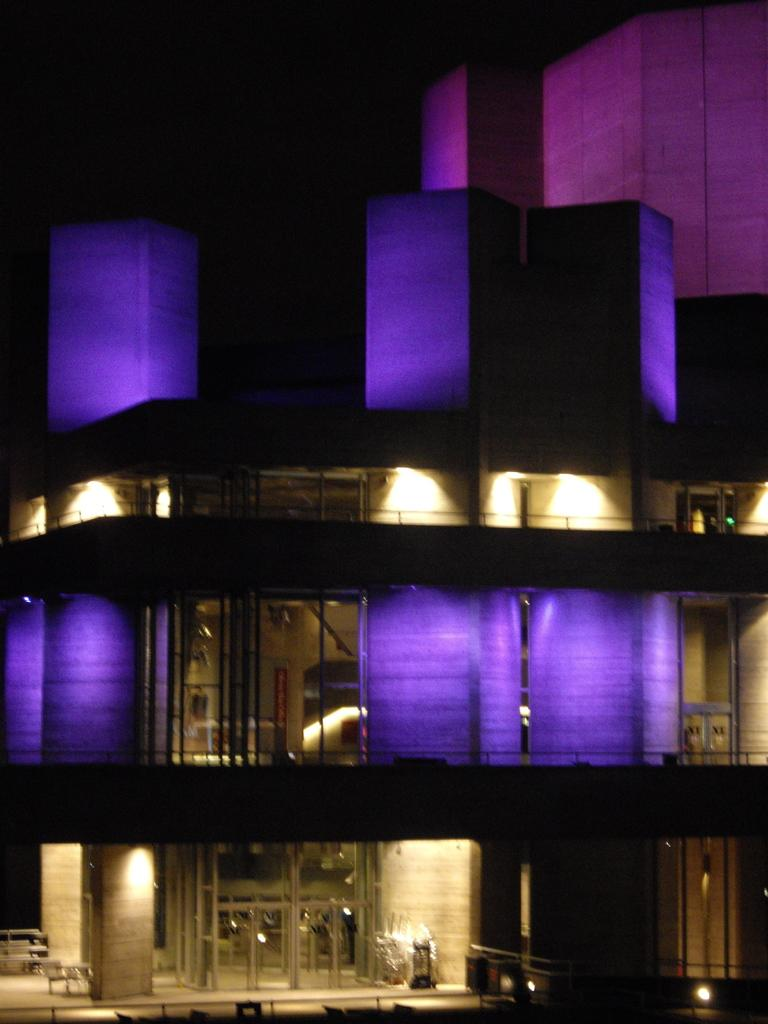What type of structure is visible in the image? There is a building in the image. Can you describe the interior of the building? There are lights inside the building. What type of furniture is present at the bottom of the image? There are tables and chairs at the bottom of the image. What type of lettuce is growing on the roof of the building in the image? There is no lettuce visible on the roof of the building in the image. 